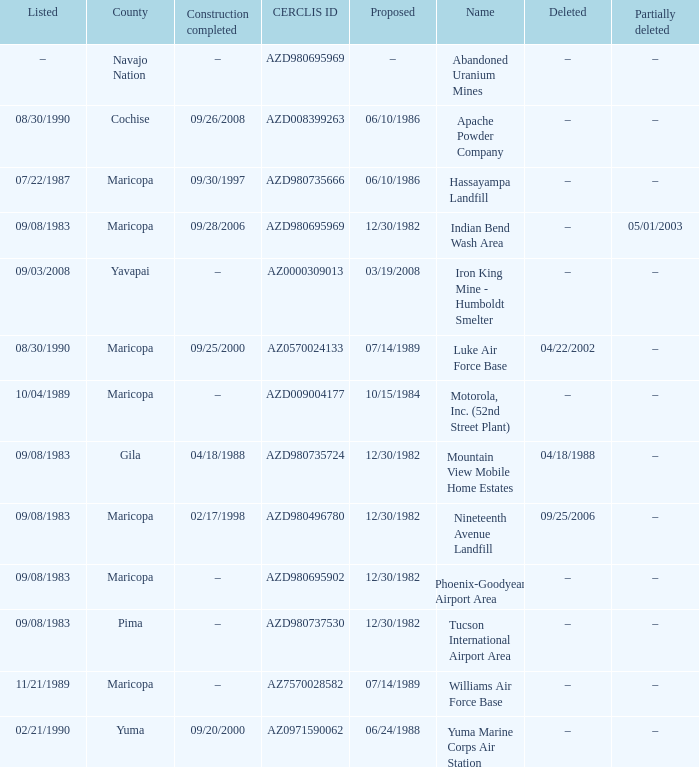What is the cerclis id when the site was proposed on 12/30/1982 and was partially deleted on 05/01/2003? AZD980695969. 